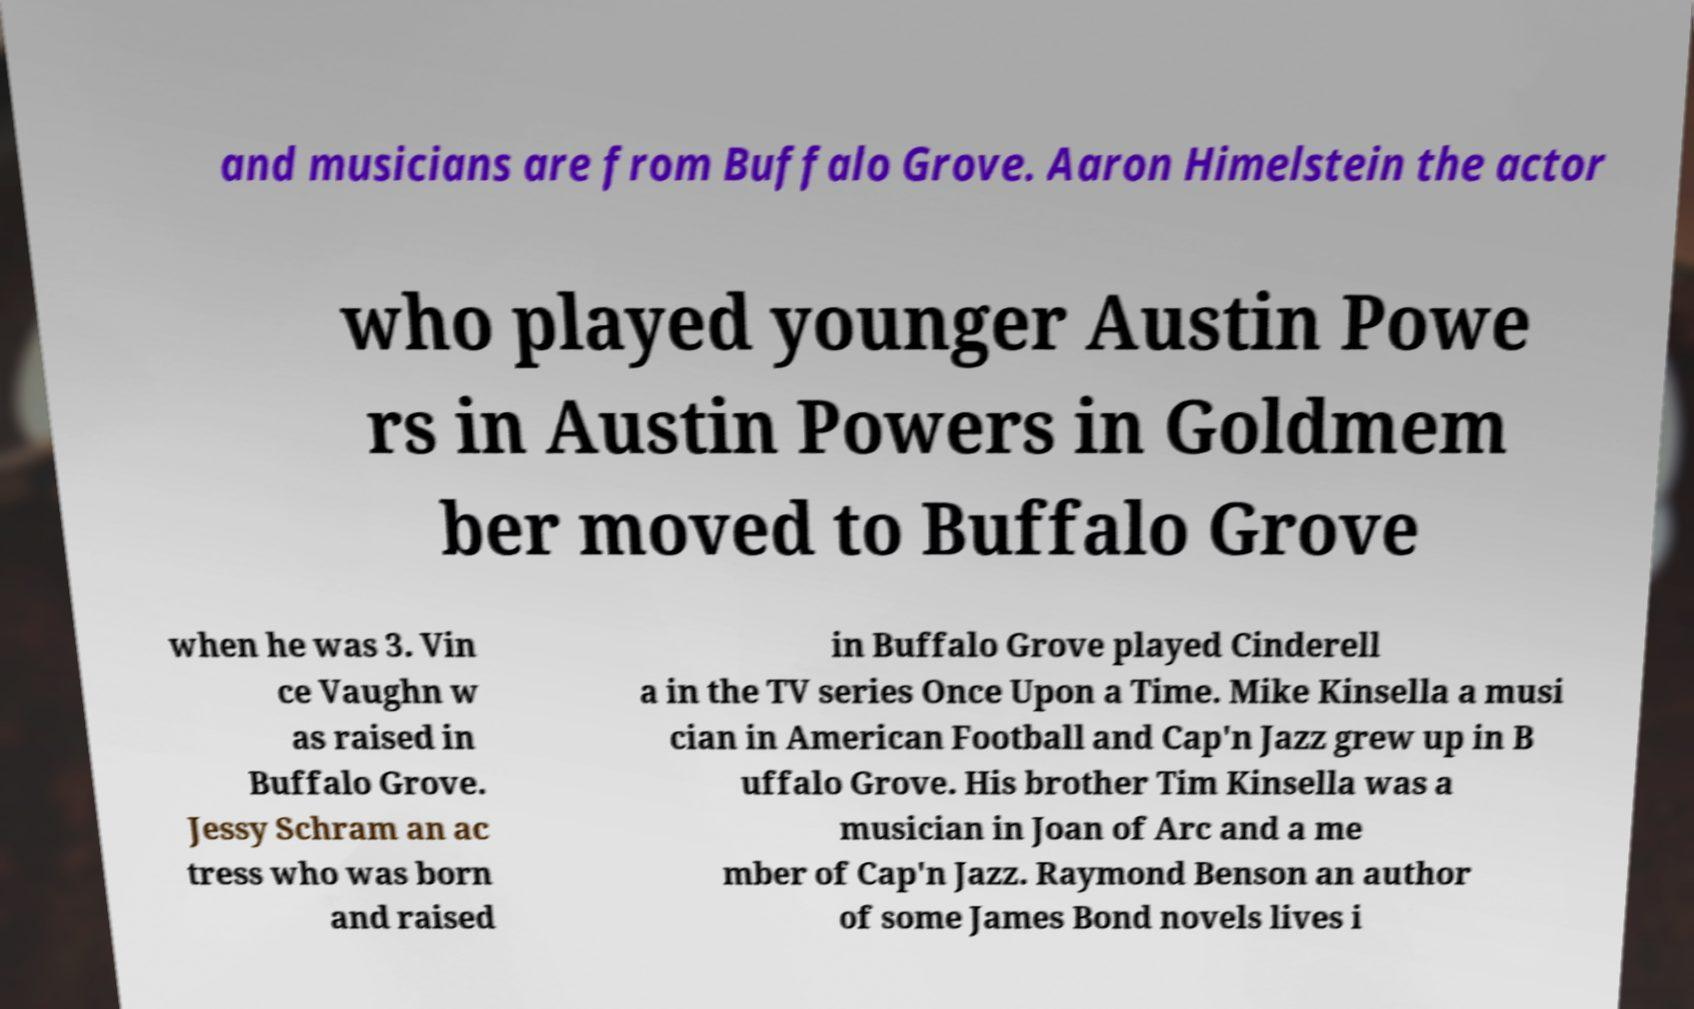I need the written content from this picture converted into text. Can you do that? and musicians are from Buffalo Grove. Aaron Himelstein the actor who played younger Austin Powe rs in Austin Powers in Goldmem ber moved to Buffalo Grove when he was 3. Vin ce Vaughn w as raised in Buffalo Grove. Jessy Schram an ac tress who was born and raised in Buffalo Grove played Cinderell a in the TV series Once Upon a Time. Mike Kinsella a musi cian in American Football and Cap'n Jazz grew up in B uffalo Grove. His brother Tim Kinsella was a musician in Joan of Arc and a me mber of Cap'n Jazz. Raymond Benson an author of some James Bond novels lives i 